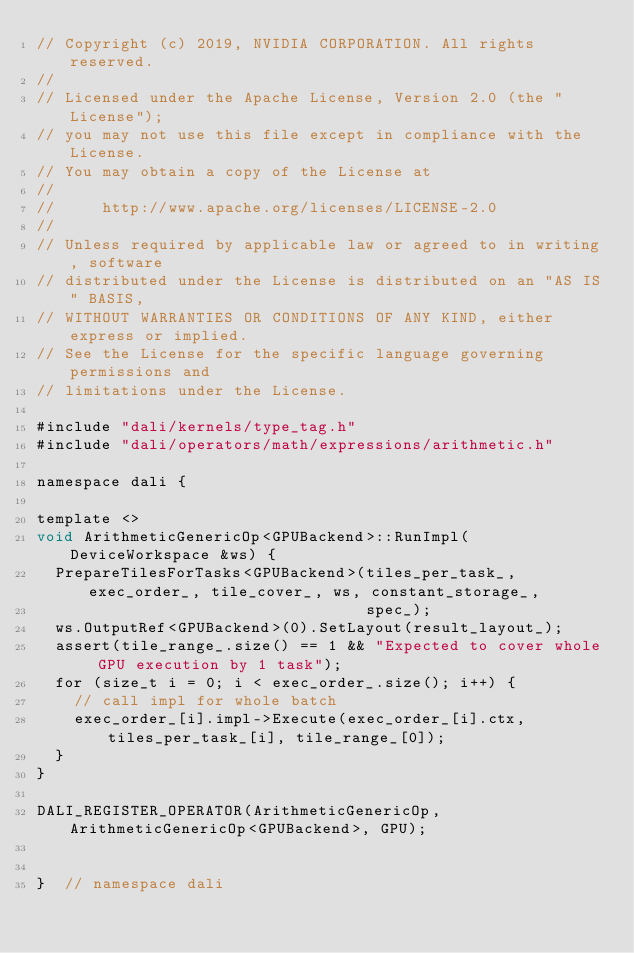<code> <loc_0><loc_0><loc_500><loc_500><_Cuda_>// Copyright (c) 2019, NVIDIA CORPORATION. All rights reserved.
//
// Licensed under the Apache License, Version 2.0 (the "License");
// you may not use this file except in compliance with the License.
// You may obtain a copy of the License at
//
//     http://www.apache.org/licenses/LICENSE-2.0
//
// Unless required by applicable law or agreed to in writing, software
// distributed under the License is distributed on an "AS IS" BASIS,
// WITHOUT WARRANTIES OR CONDITIONS OF ANY KIND, either express or implied.
// See the License for the specific language governing permissions and
// limitations under the License.

#include "dali/kernels/type_tag.h"
#include "dali/operators/math/expressions/arithmetic.h"

namespace dali {

template <>
void ArithmeticGenericOp<GPUBackend>::RunImpl(DeviceWorkspace &ws) {
  PrepareTilesForTasks<GPUBackend>(tiles_per_task_, exec_order_, tile_cover_, ws, constant_storage_,
                                   spec_);
  ws.OutputRef<GPUBackend>(0).SetLayout(result_layout_);
  assert(tile_range_.size() == 1 && "Expected to cover whole GPU execution by 1 task");
  for (size_t i = 0; i < exec_order_.size(); i++) {
    // call impl for whole batch
    exec_order_[i].impl->Execute(exec_order_[i].ctx, tiles_per_task_[i], tile_range_[0]);
  }
}

DALI_REGISTER_OPERATOR(ArithmeticGenericOp, ArithmeticGenericOp<GPUBackend>, GPU);


}  // namespace dali
</code> 